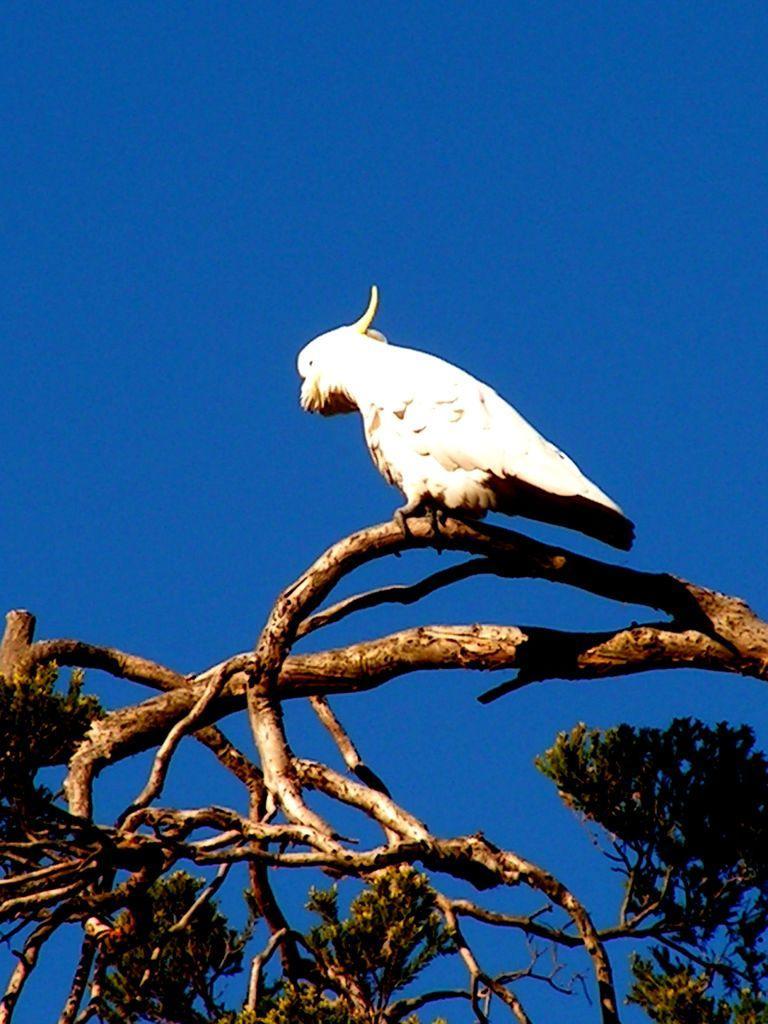Please provide a concise description of this image. In the center of the image we can see a bird on the tree. In the background there is sky. 